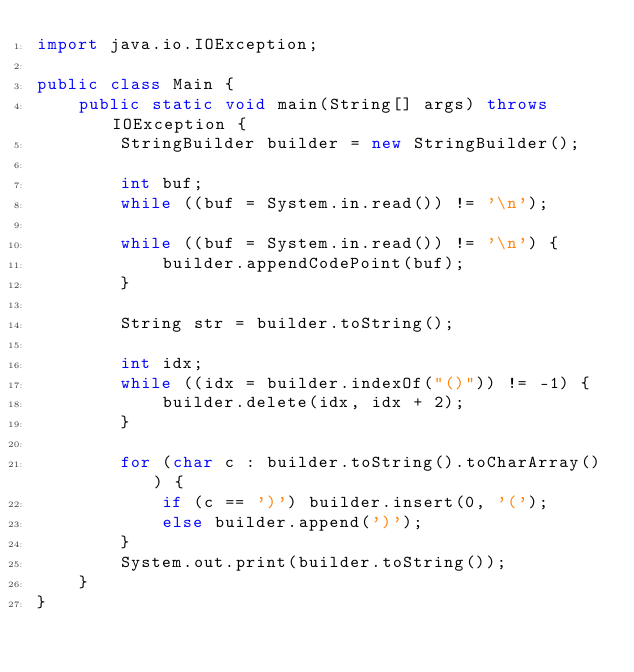<code> <loc_0><loc_0><loc_500><loc_500><_Java_>import java.io.IOException;

public class Main {
    public static void main(String[] args) throws IOException {
        StringBuilder builder = new StringBuilder();

        int buf;
        while ((buf = System.in.read()) != '\n');

        while ((buf = System.in.read()) != '\n') {
            builder.appendCodePoint(buf);
        }

        String str = builder.toString();

        int idx;
        while ((idx = builder.indexOf("()")) != -1) {
            builder.delete(idx, idx + 2);
        }

        for (char c : builder.toString().toCharArray()) {
            if (c == ')') builder.insert(0, '(');
            else builder.append(')');
        }
        System.out.print(builder.toString());
    }
}
</code> 